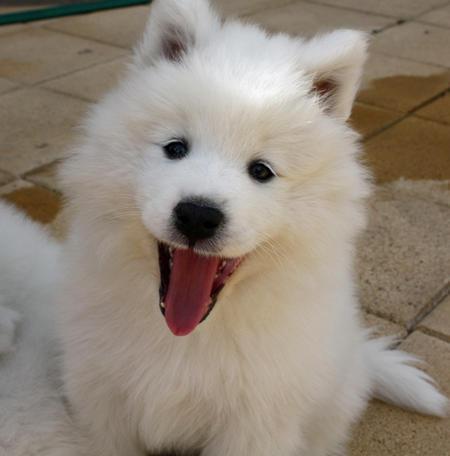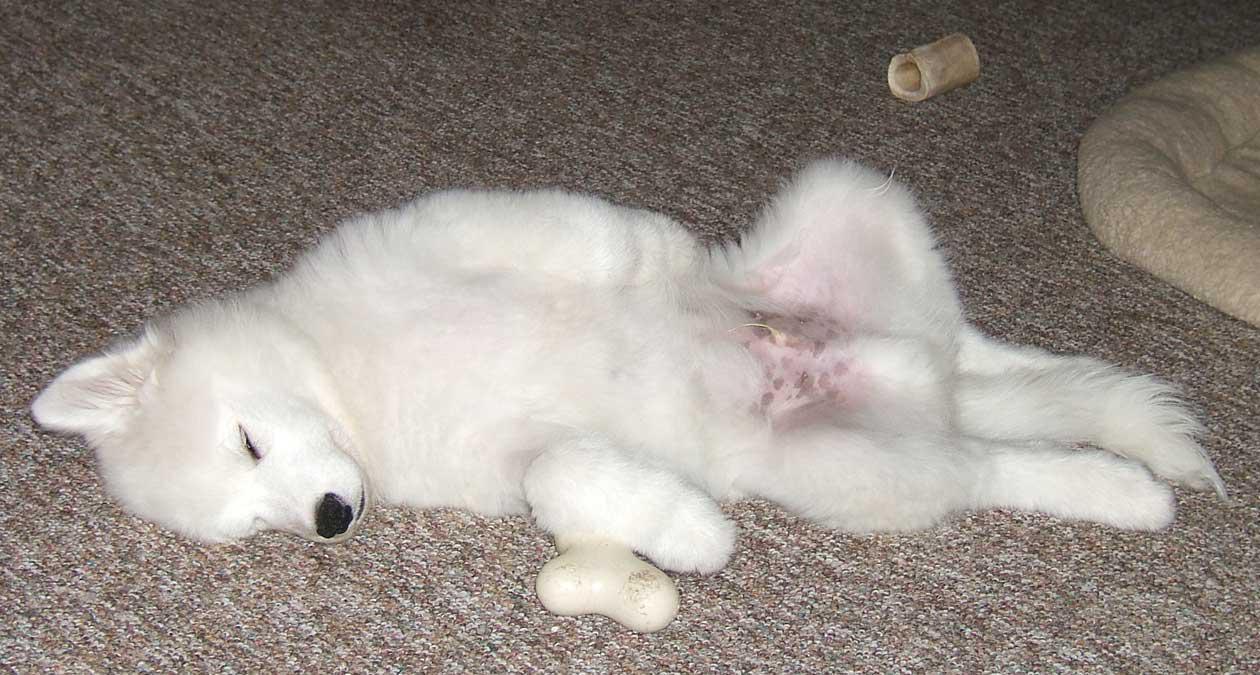The first image is the image on the left, the second image is the image on the right. Evaluate the accuracy of this statement regarding the images: "At least one dog in one of the images has its tongue hanging out.". Is it true? Answer yes or no. Yes. The first image is the image on the left, the second image is the image on the right. Evaluate the accuracy of this statement regarding the images: "Right image shows a white dog sleeping on the floor with its belly facing up.". Is it true? Answer yes or no. Yes. 